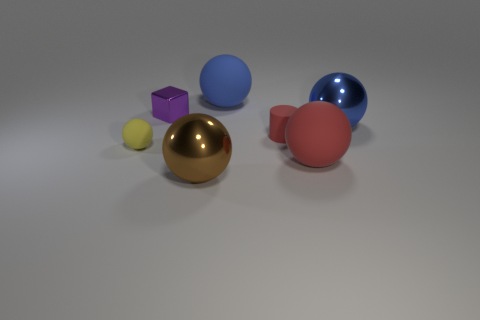Subtract all red spheres. How many spheres are left? 4 Subtract all big blue shiny balls. How many balls are left? 4 Subtract all cyan spheres. Subtract all green cubes. How many spheres are left? 5 Add 1 large blue things. How many objects exist? 8 Subtract all balls. How many objects are left? 2 Subtract all gray shiny spheres. Subtract all brown shiny spheres. How many objects are left? 6 Add 5 small yellow matte objects. How many small yellow matte objects are left? 6 Add 1 blue rubber balls. How many blue rubber balls exist? 2 Subtract 0 cyan cubes. How many objects are left? 7 